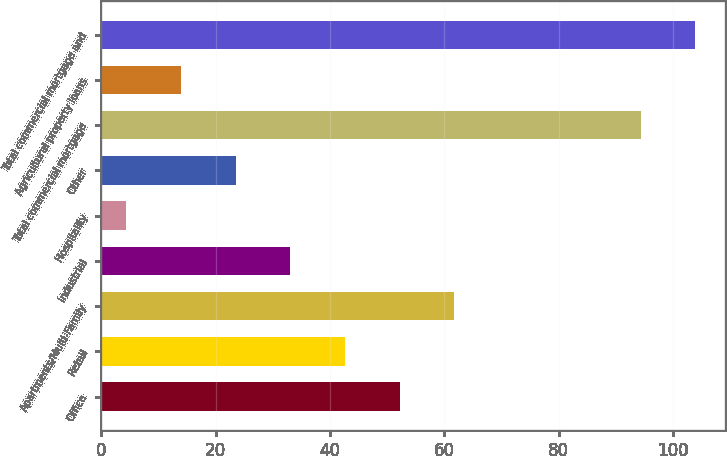Convert chart. <chart><loc_0><loc_0><loc_500><loc_500><bar_chart><fcel>Office<fcel>Retail<fcel>Apartments/Multi-Family<fcel>Industrial<fcel>Hospitality<fcel>Other<fcel>Total commercial mortgage<fcel>Agricultural property loans<fcel>Total commercial mortgage and<nl><fcel>52.2<fcel>42.64<fcel>61.76<fcel>33.08<fcel>4.4<fcel>23.52<fcel>94.3<fcel>13.96<fcel>103.86<nl></chart> 